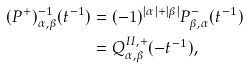<formula> <loc_0><loc_0><loc_500><loc_500>( P ^ { + } ) ^ { - 1 } _ { \alpha , \beta } ( t ^ { - 1 } ) & = ( - 1 ) ^ { | \alpha | + | \beta | } P ^ { - } _ { \beta , \alpha } ( t ^ { - 1 } ) \\ & = Q ^ { I I , + } _ { \alpha , \beta } ( - t ^ { - 1 } ) ,</formula> 